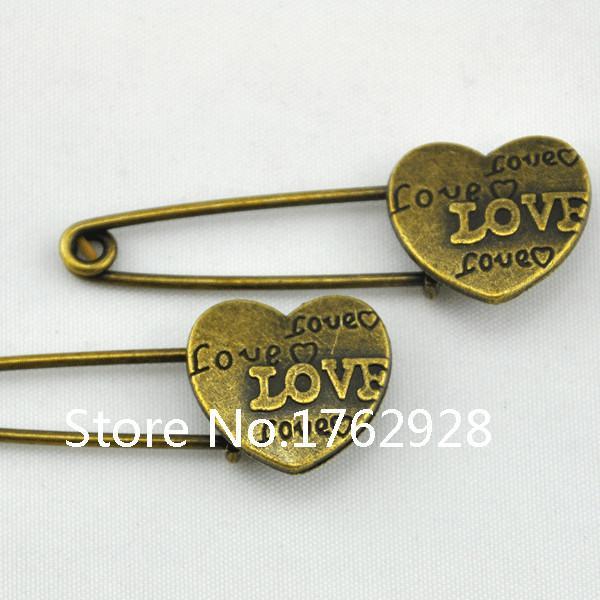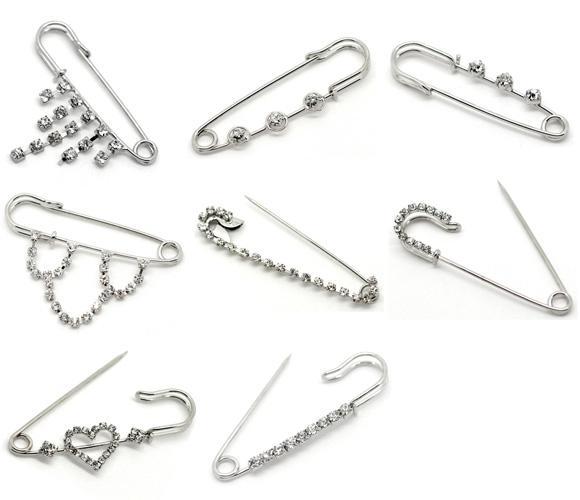The first image is the image on the left, the second image is the image on the right. Given the left and right images, does the statement "An image shows pins arranged like spokes forming a circle." hold true? Answer yes or no. No. 